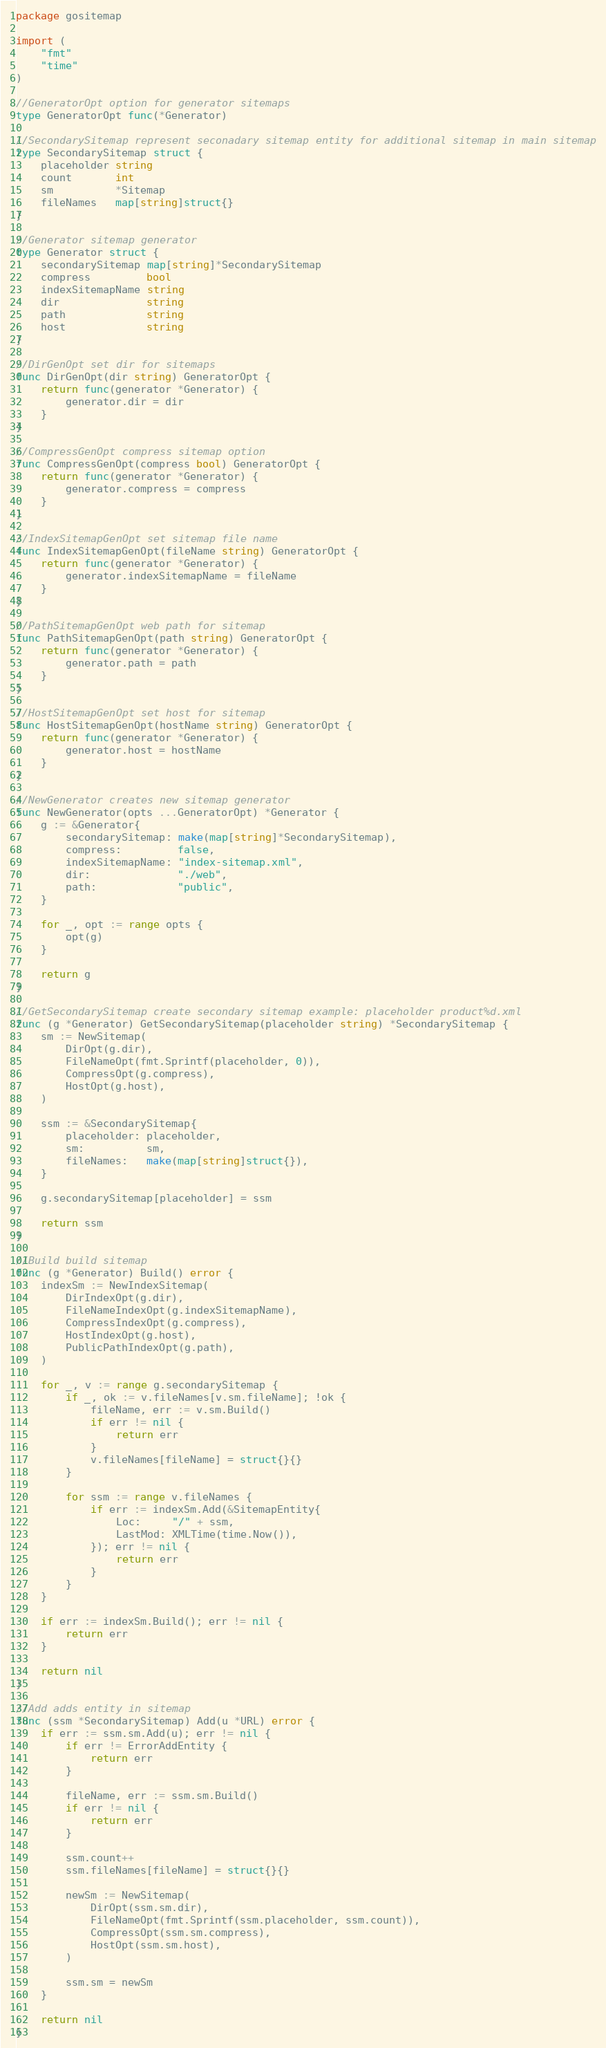Convert code to text. <code><loc_0><loc_0><loc_500><loc_500><_Go_>package gositemap

import (
	"fmt"
	"time"
)

//GeneratorOpt option for generator sitemaps
type GeneratorOpt func(*Generator)

//SecondarySitemap represent seconadary sitemap entity for additional sitemap in main sitemap
type SecondarySitemap struct {
	placeholder string
	count       int
	sm          *Sitemap
	fileNames   map[string]struct{}
}

//Generator sitemap generator
type Generator struct {
	secondarySitemap map[string]*SecondarySitemap
	compress         bool
	indexSitemapName string
	dir              string
	path             string
	host             string
}

//DirGenOpt set dir for sitemaps
func DirGenOpt(dir string) GeneratorOpt {
	return func(generator *Generator) {
		generator.dir = dir
	}
}

//CompressGenOpt compress sitemap option
func CompressGenOpt(compress bool) GeneratorOpt {
	return func(generator *Generator) {
		generator.compress = compress
	}
}

//IndexSitemapGenOpt set sitemap file name
func IndexSitemapGenOpt(fileName string) GeneratorOpt {
	return func(generator *Generator) {
		generator.indexSitemapName = fileName
	}
}

//PathSitemapGenOpt web path for sitemap
func PathSitemapGenOpt(path string) GeneratorOpt {
	return func(generator *Generator) {
		generator.path = path
	}
}

//HostSitemapGenOpt set host for sitemap
func HostSitemapGenOpt(hostName string) GeneratorOpt {
	return func(generator *Generator) {
		generator.host = hostName
	}
}

//NewGenerator creates new sitemap generator
func NewGenerator(opts ...GeneratorOpt) *Generator {
	g := &Generator{
		secondarySitemap: make(map[string]*SecondarySitemap),
		compress:         false,
		indexSitemapName: "index-sitemap.xml",
		dir:              "./web",
		path:             "public",
	}

	for _, opt := range opts {
		opt(g)
	}

	return g
}

//GetSecondarySitemap create secondary sitemap example: placeholder product%d.xml
func (g *Generator) GetSecondarySitemap(placeholder string) *SecondarySitemap {
	sm := NewSitemap(
		DirOpt(g.dir),
		FileNameOpt(fmt.Sprintf(placeholder, 0)),
		CompressOpt(g.compress),
		HostOpt(g.host),
	)

	ssm := &SecondarySitemap{
		placeholder: placeholder,
		sm:          sm,
		fileNames:   make(map[string]struct{}),
	}

	g.secondarySitemap[placeholder] = ssm

	return ssm
}

//Build build sitemap
func (g *Generator) Build() error {
	indexSm := NewIndexSitemap(
		DirIndexOpt(g.dir),
		FileNameIndexOpt(g.indexSitemapName),
		CompressIndexOpt(g.compress),
		HostIndexOpt(g.host),
		PublicPathIndexOpt(g.path),
	)

	for _, v := range g.secondarySitemap {
		if _, ok := v.fileNames[v.sm.fileName]; !ok {
			fileName, err := v.sm.Build()
			if err != nil {
				return err
			}
			v.fileNames[fileName] = struct{}{}
		}

		for ssm := range v.fileNames {
			if err := indexSm.Add(&SitemapEntity{
				Loc:     "/" + ssm,
				LastMod: XMLTime(time.Now()),
			}); err != nil {
				return err
			}
		}
	}

	if err := indexSm.Build(); err != nil {
		return err
	}

	return nil
}

//Add adds entity in sitemap
func (ssm *SecondarySitemap) Add(u *URL) error {
	if err := ssm.sm.Add(u); err != nil {
		if err != ErrorAddEntity {
			return err
		}

		fileName, err := ssm.sm.Build()
		if err != nil {
			return err
		}

		ssm.count++
		ssm.fileNames[fileName] = struct{}{}

		newSm := NewSitemap(
			DirOpt(ssm.sm.dir),
			FileNameOpt(fmt.Sprintf(ssm.placeholder, ssm.count)),
			CompressOpt(ssm.sm.compress),
			HostOpt(ssm.sm.host),
		)

		ssm.sm = newSm
	}

	return nil
}
</code> 